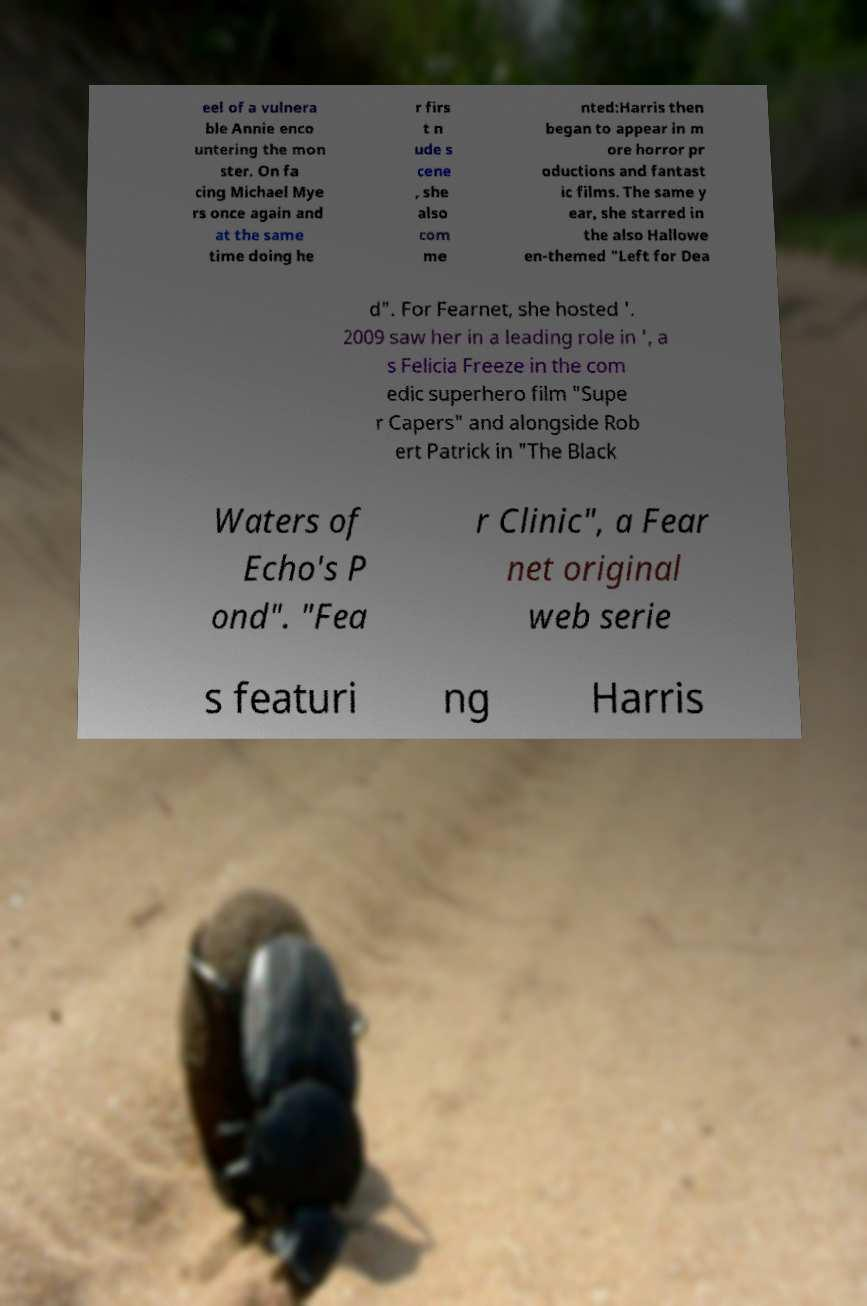Please identify and transcribe the text found in this image. eel of a vulnera ble Annie enco untering the mon ster. On fa cing Michael Mye rs once again and at the same time doing he r firs t n ude s cene , she also com me nted:Harris then began to appear in m ore horror pr oductions and fantast ic films. The same y ear, she starred in the also Hallowe en-themed "Left for Dea d". For Fearnet, she hosted '. 2009 saw her in a leading role in ', a s Felicia Freeze in the com edic superhero film "Supe r Capers" and alongside Rob ert Patrick in "The Black Waters of Echo's P ond". "Fea r Clinic", a Fear net original web serie s featuri ng Harris 